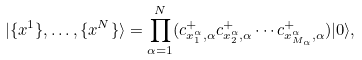Convert formula to latex. <formula><loc_0><loc_0><loc_500><loc_500>| \{ x ^ { 1 } \} , \dots , \{ x ^ { N } \} \rangle = \prod _ { \alpha = 1 } ^ { N } ( c ^ { + } _ { x ^ { \alpha } _ { 1 } , \alpha } c ^ { + } _ { x ^ { \alpha } _ { 2 } , \alpha } \cdots c ^ { + } _ { x ^ { \alpha } _ { M _ { \alpha } } , \alpha } ) | 0 \rangle ,</formula> 